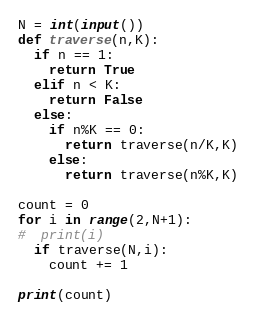<code> <loc_0><loc_0><loc_500><loc_500><_Python_>N = int(input())
def traverse(n,K):
  if n == 1:
    return True
  elif n < K:
    return False
  else:
    if n%K == 0:
      return traverse(n/K,K)
    else:
      return traverse(n%K,K)

count = 0
for i in range(2,N+1):
#  print(i)
  if traverse(N,i):
    count += 1

print(count)</code> 